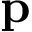<formula> <loc_0><loc_0><loc_500><loc_500>p</formula> 